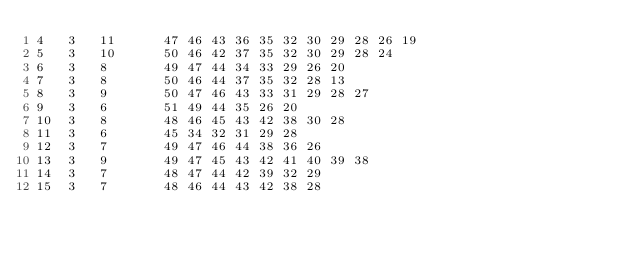<code> <loc_0><loc_0><loc_500><loc_500><_ObjectiveC_>4	3	11		47 46 43 36 35 32 30 29 28 26 19 
5	3	10		50 46 42 37 35 32 30 29 28 24 
6	3	8		49 47 44 34 33 29 26 20 
7	3	8		50 46 44 37 35 32 28 13 
8	3	9		50 47 46 43 33 31 29 28 27 
9	3	6		51 49 44 35 26 20 
10	3	8		48 46 45 43 42 38 30 28 
11	3	6		45 34 32 31 29 28 
12	3	7		49 47 46 44 38 36 26 
13	3	9		49 47 45 43 42 41 40 39 38 
14	3	7		48 47 44 42 39 32 29 
15	3	7		48 46 44 43 42 38 28 </code> 